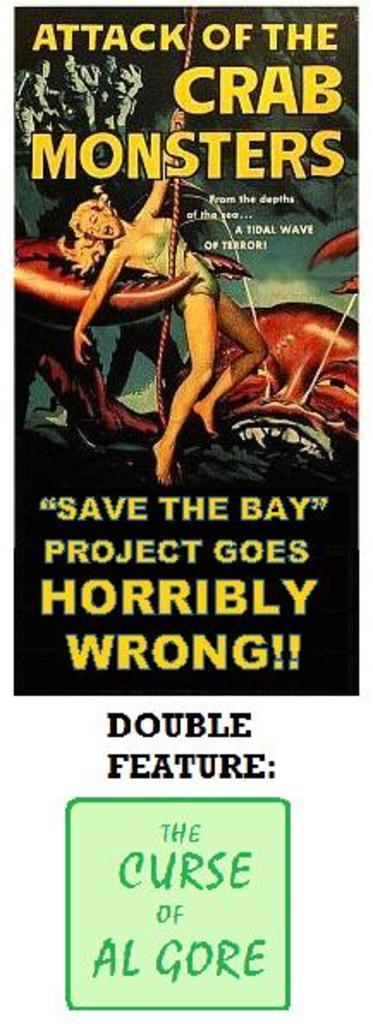Provide a one-sentence caption for the provided image. Poster with an alien grabbing a woman titled "Attack of the Crab Monsters". 